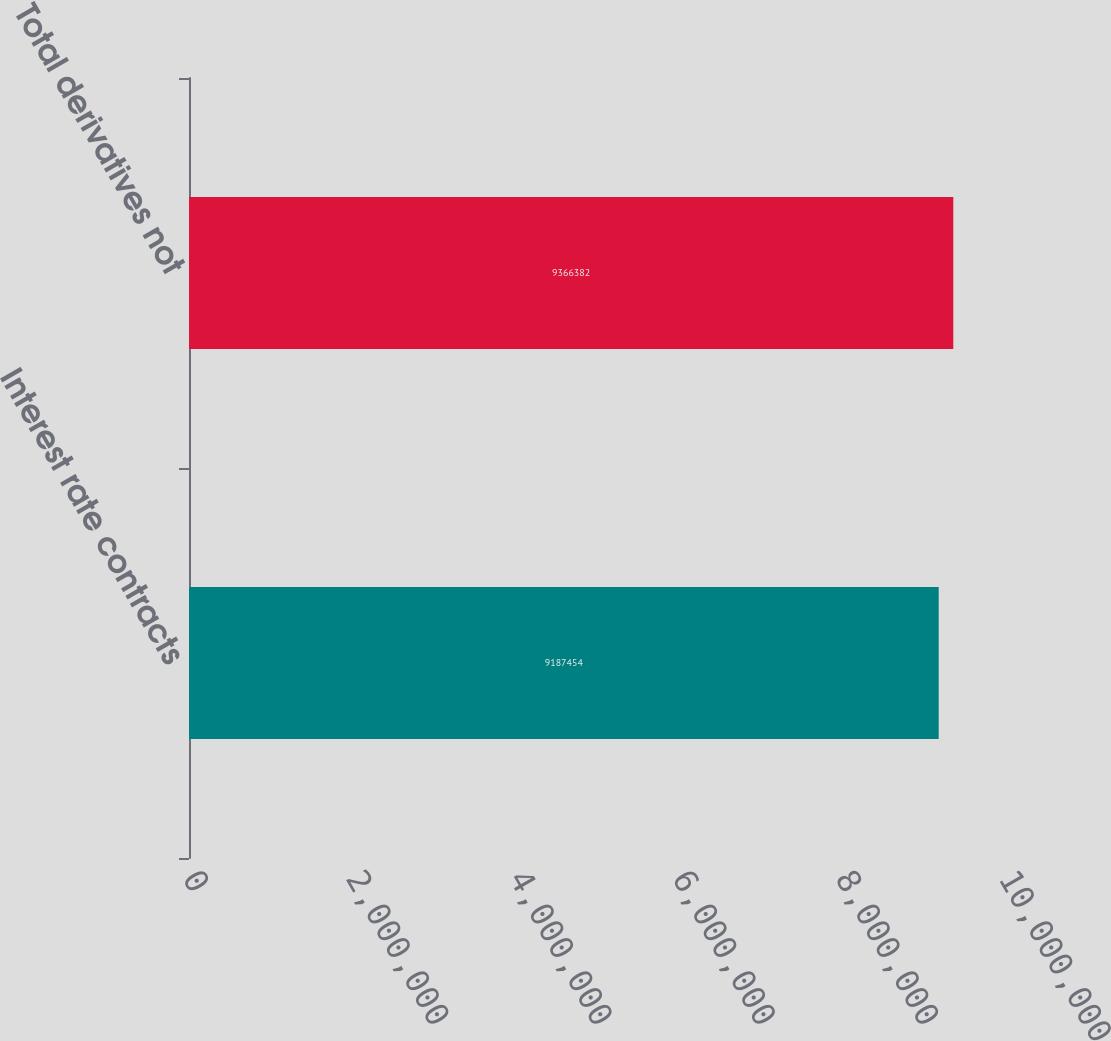Convert chart to OTSL. <chart><loc_0><loc_0><loc_500><loc_500><bar_chart><fcel>Interest rate contracts<fcel>Total derivatives not<nl><fcel>9.18745e+06<fcel>9.36638e+06<nl></chart> 